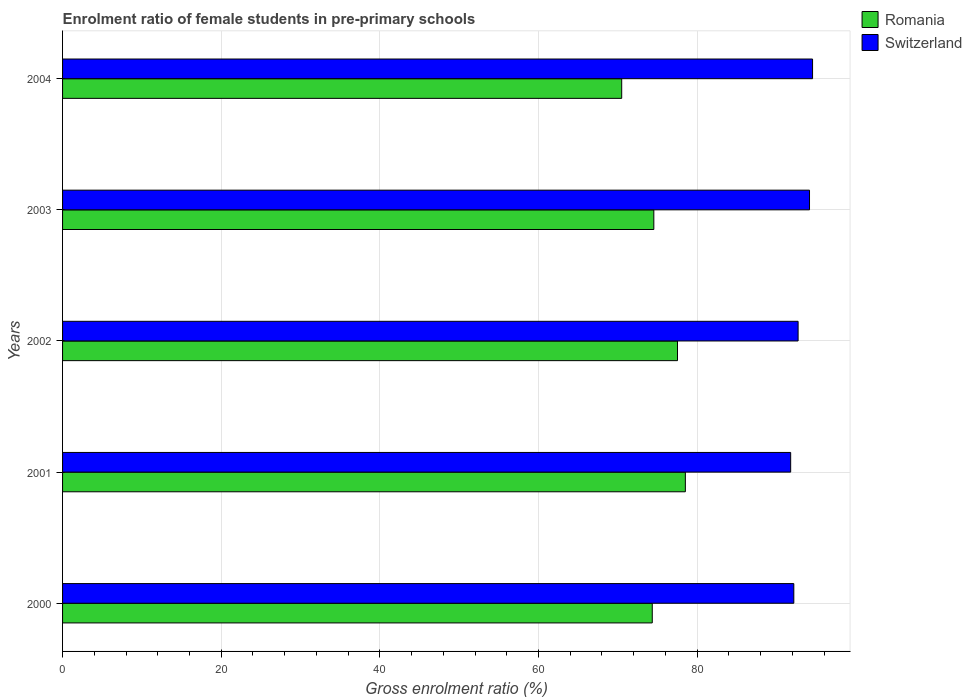How many different coloured bars are there?
Your response must be concise. 2. Are the number of bars per tick equal to the number of legend labels?
Keep it short and to the point. Yes. How many bars are there on the 5th tick from the top?
Give a very brief answer. 2. In how many cases, is the number of bars for a given year not equal to the number of legend labels?
Make the answer very short. 0. What is the enrolment ratio of female students in pre-primary schools in Romania in 2002?
Your answer should be compact. 77.52. Across all years, what is the maximum enrolment ratio of female students in pre-primary schools in Switzerland?
Give a very brief answer. 94.55. Across all years, what is the minimum enrolment ratio of female students in pre-primary schools in Romania?
Give a very brief answer. 70.49. In which year was the enrolment ratio of female students in pre-primary schools in Switzerland maximum?
Your answer should be compact. 2004. In which year was the enrolment ratio of female students in pre-primary schools in Romania minimum?
Offer a very short reply. 2004. What is the total enrolment ratio of female students in pre-primary schools in Switzerland in the graph?
Offer a terse response. 465.4. What is the difference between the enrolment ratio of female students in pre-primary schools in Romania in 2002 and that in 2003?
Ensure brevity in your answer.  2.98. What is the difference between the enrolment ratio of female students in pre-primary schools in Romania in 2000 and the enrolment ratio of female students in pre-primary schools in Switzerland in 2001?
Provide a short and direct response. -17.45. What is the average enrolment ratio of female students in pre-primary schools in Switzerland per year?
Provide a short and direct response. 93.08. In the year 2002, what is the difference between the enrolment ratio of female students in pre-primary schools in Switzerland and enrolment ratio of female students in pre-primary schools in Romania?
Provide a succinct answer. 15.2. In how many years, is the enrolment ratio of female students in pre-primary schools in Romania greater than 84 %?
Your response must be concise. 0. What is the ratio of the enrolment ratio of female students in pre-primary schools in Switzerland in 2002 to that in 2003?
Offer a terse response. 0.98. Is the enrolment ratio of female students in pre-primary schools in Switzerland in 2000 less than that in 2001?
Your answer should be very brief. No. Is the difference between the enrolment ratio of female students in pre-primary schools in Switzerland in 2000 and 2001 greater than the difference between the enrolment ratio of female students in pre-primary schools in Romania in 2000 and 2001?
Give a very brief answer. Yes. What is the difference between the highest and the second highest enrolment ratio of female students in pre-primary schools in Switzerland?
Make the answer very short. 0.38. What is the difference between the highest and the lowest enrolment ratio of female students in pre-primary schools in Switzerland?
Provide a succinct answer. 2.76. What does the 2nd bar from the top in 2002 represents?
Make the answer very short. Romania. What does the 1st bar from the bottom in 2003 represents?
Provide a short and direct response. Romania. How many bars are there?
Your answer should be very brief. 10. Are all the bars in the graph horizontal?
Your answer should be very brief. Yes. What is the difference between two consecutive major ticks on the X-axis?
Ensure brevity in your answer.  20. Are the values on the major ticks of X-axis written in scientific E-notation?
Offer a terse response. No. Does the graph contain any zero values?
Keep it short and to the point. No. Where does the legend appear in the graph?
Your response must be concise. Top right. How are the legend labels stacked?
Make the answer very short. Vertical. What is the title of the graph?
Provide a short and direct response. Enrolment ratio of female students in pre-primary schools. What is the label or title of the X-axis?
Offer a very short reply. Gross enrolment ratio (%). What is the Gross enrolment ratio (%) of Romania in 2000?
Offer a terse response. 74.34. What is the Gross enrolment ratio (%) in Switzerland in 2000?
Keep it short and to the point. 92.18. What is the Gross enrolment ratio (%) of Romania in 2001?
Provide a succinct answer. 78.51. What is the Gross enrolment ratio (%) of Switzerland in 2001?
Give a very brief answer. 91.79. What is the Gross enrolment ratio (%) in Romania in 2002?
Keep it short and to the point. 77.52. What is the Gross enrolment ratio (%) of Switzerland in 2002?
Provide a succinct answer. 92.72. What is the Gross enrolment ratio (%) in Romania in 2003?
Offer a terse response. 74.54. What is the Gross enrolment ratio (%) of Switzerland in 2003?
Your answer should be very brief. 94.16. What is the Gross enrolment ratio (%) in Romania in 2004?
Your answer should be compact. 70.49. What is the Gross enrolment ratio (%) in Switzerland in 2004?
Give a very brief answer. 94.55. Across all years, what is the maximum Gross enrolment ratio (%) in Romania?
Provide a short and direct response. 78.51. Across all years, what is the maximum Gross enrolment ratio (%) in Switzerland?
Keep it short and to the point. 94.55. Across all years, what is the minimum Gross enrolment ratio (%) of Romania?
Make the answer very short. 70.49. Across all years, what is the minimum Gross enrolment ratio (%) in Switzerland?
Provide a short and direct response. 91.79. What is the total Gross enrolment ratio (%) of Romania in the graph?
Keep it short and to the point. 375.39. What is the total Gross enrolment ratio (%) of Switzerland in the graph?
Keep it short and to the point. 465.4. What is the difference between the Gross enrolment ratio (%) in Romania in 2000 and that in 2001?
Keep it short and to the point. -4.17. What is the difference between the Gross enrolment ratio (%) in Switzerland in 2000 and that in 2001?
Keep it short and to the point. 0.4. What is the difference between the Gross enrolment ratio (%) in Romania in 2000 and that in 2002?
Provide a short and direct response. -3.18. What is the difference between the Gross enrolment ratio (%) in Switzerland in 2000 and that in 2002?
Your answer should be very brief. -0.54. What is the difference between the Gross enrolment ratio (%) of Romania in 2000 and that in 2003?
Offer a very short reply. -0.2. What is the difference between the Gross enrolment ratio (%) in Switzerland in 2000 and that in 2003?
Keep it short and to the point. -1.98. What is the difference between the Gross enrolment ratio (%) in Romania in 2000 and that in 2004?
Provide a short and direct response. 3.85. What is the difference between the Gross enrolment ratio (%) of Switzerland in 2000 and that in 2004?
Your answer should be compact. -2.36. What is the difference between the Gross enrolment ratio (%) in Romania in 2001 and that in 2002?
Provide a short and direct response. 0.99. What is the difference between the Gross enrolment ratio (%) of Switzerland in 2001 and that in 2002?
Provide a short and direct response. -0.94. What is the difference between the Gross enrolment ratio (%) of Romania in 2001 and that in 2003?
Offer a terse response. 3.97. What is the difference between the Gross enrolment ratio (%) in Switzerland in 2001 and that in 2003?
Offer a terse response. -2.38. What is the difference between the Gross enrolment ratio (%) in Romania in 2001 and that in 2004?
Your answer should be compact. 8.03. What is the difference between the Gross enrolment ratio (%) in Switzerland in 2001 and that in 2004?
Your answer should be compact. -2.76. What is the difference between the Gross enrolment ratio (%) in Romania in 2002 and that in 2003?
Your response must be concise. 2.98. What is the difference between the Gross enrolment ratio (%) of Switzerland in 2002 and that in 2003?
Keep it short and to the point. -1.44. What is the difference between the Gross enrolment ratio (%) of Romania in 2002 and that in 2004?
Your answer should be very brief. 7.04. What is the difference between the Gross enrolment ratio (%) in Switzerland in 2002 and that in 2004?
Make the answer very short. -1.82. What is the difference between the Gross enrolment ratio (%) in Romania in 2003 and that in 2004?
Ensure brevity in your answer.  4.05. What is the difference between the Gross enrolment ratio (%) of Switzerland in 2003 and that in 2004?
Keep it short and to the point. -0.38. What is the difference between the Gross enrolment ratio (%) in Romania in 2000 and the Gross enrolment ratio (%) in Switzerland in 2001?
Ensure brevity in your answer.  -17.45. What is the difference between the Gross enrolment ratio (%) of Romania in 2000 and the Gross enrolment ratio (%) of Switzerland in 2002?
Keep it short and to the point. -18.38. What is the difference between the Gross enrolment ratio (%) in Romania in 2000 and the Gross enrolment ratio (%) in Switzerland in 2003?
Give a very brief answer. -19.82. What is the difference between the Gross enrolment ratio (%) of Romania in 2000 and the Gross enrolment ratio (%) of Switzerland in 2004?
Your response must be concise. -20.21. What is the difference between the Gross enrolment ratio (%) in Romania in 2001 and the Gross enrolment ratio (%) in Switzerland in 2002?
Offer a very short reply. -14.21. What is the difference between the Gross enrolment ratio (%) in Romania in 2001 and the Gross enrolment ratio (%) in Switzerland in 2003?
Provide a succinct answer. -15.65. What is the difference between the Gross enrolment ratio (%) in Romania in 2001 and the Gross enrolment ratio (%) in Switzerland in 2004?
Provide a short and direct response. -16.03. What is the difference between the Gross enrolment ratio (%) of Romania in 2002 and the Gross enrolment ratio (%) of Switzerland in 2003?
Make the answer very short. -16.64. What is the difference between the Gross enrolment ratio (%) in Romania in 2002 and the Gross enrolment ratio (%) in Switzerland in 2004?
Provide a short and direct response. -17.02. What is the difference between the Gross enrolment ratio (%) of Romania in 2003 and the Gross enrolment ratio (%) of Switzerland in 2004?
Provide a short and direct response. -20.01. What is the average Gross enrolment ratio (%) of Romania per year?
Offer a very short reply. 75.08. What is the average Gross enrolment ratio (%) in Switzerland per year?
Your response must be concise. 93.08. In the year 2000, what is the difference between the Gross enrolment ratio (%) of Romania and Gross enrolment ratio (%) of Switzerland?
Your answer should be very brief. -17.84. In the year 2001, what is the difference between the Gross enrolment ratio (%) of Romania and Gross enrolment ratio (%) of Switzerland?
Your answer should be very brief. -13.28. In the year 2002, what is the difference between the Gross enrolment ratio (%) in Romania and Gross enrolment ratio (%) in Switzerland?
Offer a very short reply. -15.2. In the year 2003, what is the difference between the Gross enrolment ratio (%) in Romania and Gross enrolment ratio (%) in Switzerland?
Provide a succinct answer. -19.63. In the year 2004, what is the difference between the Gross enrolment ratio (%) in Romania and Gross enrolment ratio (%) in Switzerland?
Give a very brief answer. -24.06. What is the ratio of the Gross enrolment ratio (%) of Romania in 2000 to that in 2001?
Your response must be concise. 0.95. What is the ratio of the Gross enrolment ratio (%) in Switzerland in 2000 to that in 2001?
Keep it short and to the point. 1. What is the ratio of the Gross enrolment ratio (%) of Switzerland in 2000 to that in 2003?
Keep it short and to the point. 0.98. What is the ratio of the Gross enrolment ratio (%) of Romania in 2000 to that in 2004?
Your answer should be compact. 1.05. What is the ratio of the Gross enrolment ratio (%) in Switzerland in 2000 to that in 2004?
Offer a terse response. 0.97. What is the ratio of the Gross enrolment ratio (%) in Romania in 2001 to that in 2002?
Make the answer very short. 1.01. What is the ratio of the Gross enrolment ratio (%) of Switzerland in 2001 to that in 2002?
Your response must be concise. 0.99. What is the ratio of the Gross enrolment ratio (%) of Romania in 2001 to that in 2003?
Provide a succinct answer. 1.05. What is the ratio of the Gross enrolment ratio (%) of Switzerland in 2001 to that in 2003?
Make the answer very short. 0.97. What is the ratio of the Gross enrolment ratio (%) of Romania in 2001 to that in 2004?
Give a very brief answer. 1.11. What is the ratio of the Gross enrolment ratio (%) in Switzerland in 2001 to that in 2004?
Give a very brief answer. 0.97. What is the ratio of the Gross enrolment ratio (%) of Switzerland in 2002 to that in 2003?
Your answer should be very brief. 0.98. What is the ratio of the Gross enrolment ratio (%) of Romania in 2002 to that in 2004?
Keep it short and to the point. 1.1. What is the ratio of the Gross enrolment ratio (%) in Switzerland in 2002 to that in 2004?
Keep it short and to the point. 0.98. What is the ratio of the Gross enrolment ratio (%) in Romania in 2003 to that in 2004?
Keep it short and to the point. 1.06. What is the difference between the highest and the second highest Gross enrolment ratio (%) of Switzerland?
Offer a very short reply. 0.38. What is the difference between the highest and the lowest Gross enrolment ratio (%) of Romania?
Make the answer very short. 8.03. What is the difference between the highest and the lowest Gross enrolment ratio (%) in Switzerland?
Keep it short and to the point. 2.76. 